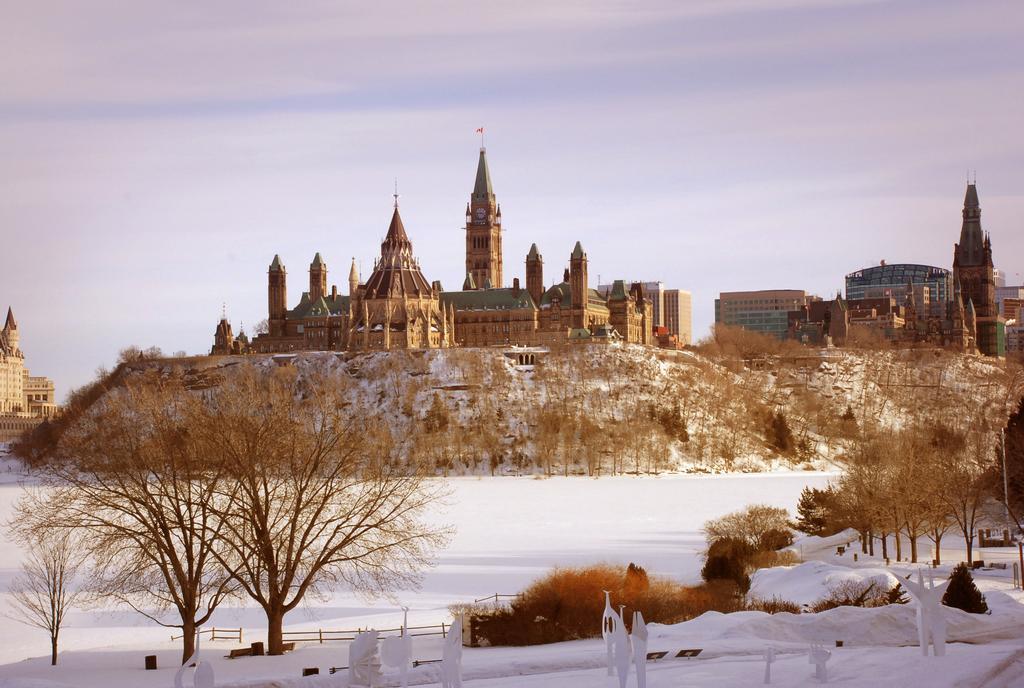Could you give a brief overview of what you see in this image? In the center of the image there is a castle. There is snow at the bottom of the image. There are trees. 